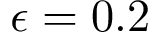<formula> <loc_0><loc_0><loc_500><loc_500>\epsilon = 0 . 2</formula> 